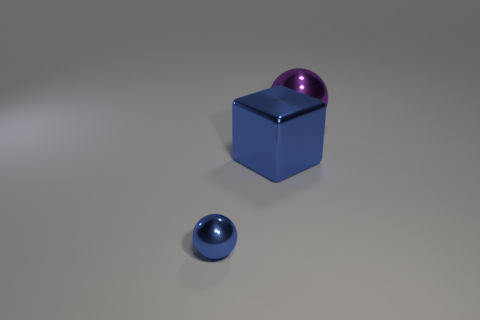There is a blue thing that is the same size as the purple metal thing; what is its material? Based on the image, the blue object appears to have a metallic sheen, similar to the surface reflection and color saturation of the purple object which was identified as metal. Therefore, it is likely that the blue object is also made of metal. 